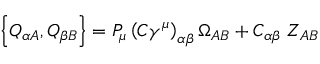Convert formula to latex. <formula><loc_0><loc_0><loc_500><loc_500>\left \{ Q _ { \alpha A } , Q _ { \beta B } \right \} = P _ { \mu } \left ( C \gamma ^ { \mu } \right ) _ { \alpha \beta } \Omega _ { A B } + C _ { \alpha \beta } \, Z _ { A B }</formula> 